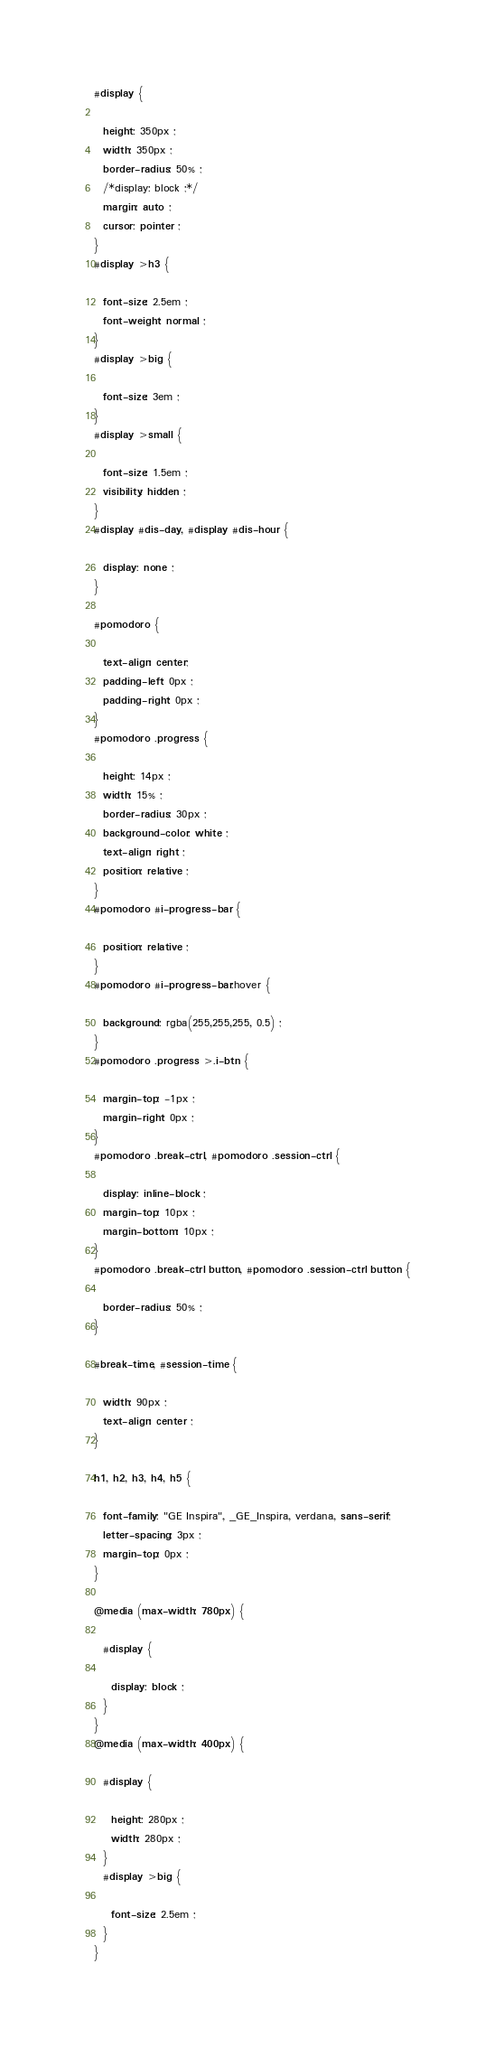Convert code to text. <code><loc_0><loc_0><loc_500><loc_500><_CSS_>#display {
 
  height: 350px ;
  width: 350px ;
  border-radius: 50% ;
  /*display: block ;*/
  margin: auto ;
  cursor: pointer ;
}
#display >h3 {
 
  font-size: 2.5em ;
  font-weight: normal ;
}
#display >big {
 
  font-size: 3em ;
}
#display >small {
 
  font-size: 1.5em ;
  visibility: hidden ;
}
#display #dis-day, #display #dis-hour {
 
  display: none ;
}

#pomodoro {
  
  text-align: center;
  padding-left: 0px ;
  padding-right: 0px ;
}
#pomodoro .progress {
  
  height: 14px ;
  width: 15% ;
  border-radius: 30px ;
  background-color: white ;
  text-align: right ;
  position: relative ;
}
#pomodoro #i-progress-bar {
  
  position: relative ;
}
#pomodoro #i-progress-bar:hover {
  
  background: rgba(255,255,255, 0.5) ;
}
#pomodoro .progress >.i-btn {
  
  margin-top: -1px ;
  margin-right: 0px ;
}
#pomodoro .break-ctrl, #pomodoro .session-ctrl {
  
  display: inline-block ;
  margin-top: 10px ;
  margin-bottom: 10px ;
}
#pomodoro .break-ctrl button, #pomodoro .session-ctrl button {
  
  border-radius: 50% ;
}

#break-time, #session-time {
  
  width: 90px ;
  text-align: center ;
} 

h1, h2, h3, h4, h5 {

  font-family: "GE Inspira", _GE_Inspira, verdana, sans-serif;
  letter-spacing: 3px ;
  margin-top: 0px ;
}

@media (max-width: 780px) {
  
  #display {

    display: block ;
  }
}
@media (max-width: 400px) {
  
  #display {

    height: 280px ;
    width: 280px ;
  }
  #display >big {

    font-size: 2.5em ;
  }
}</code> 